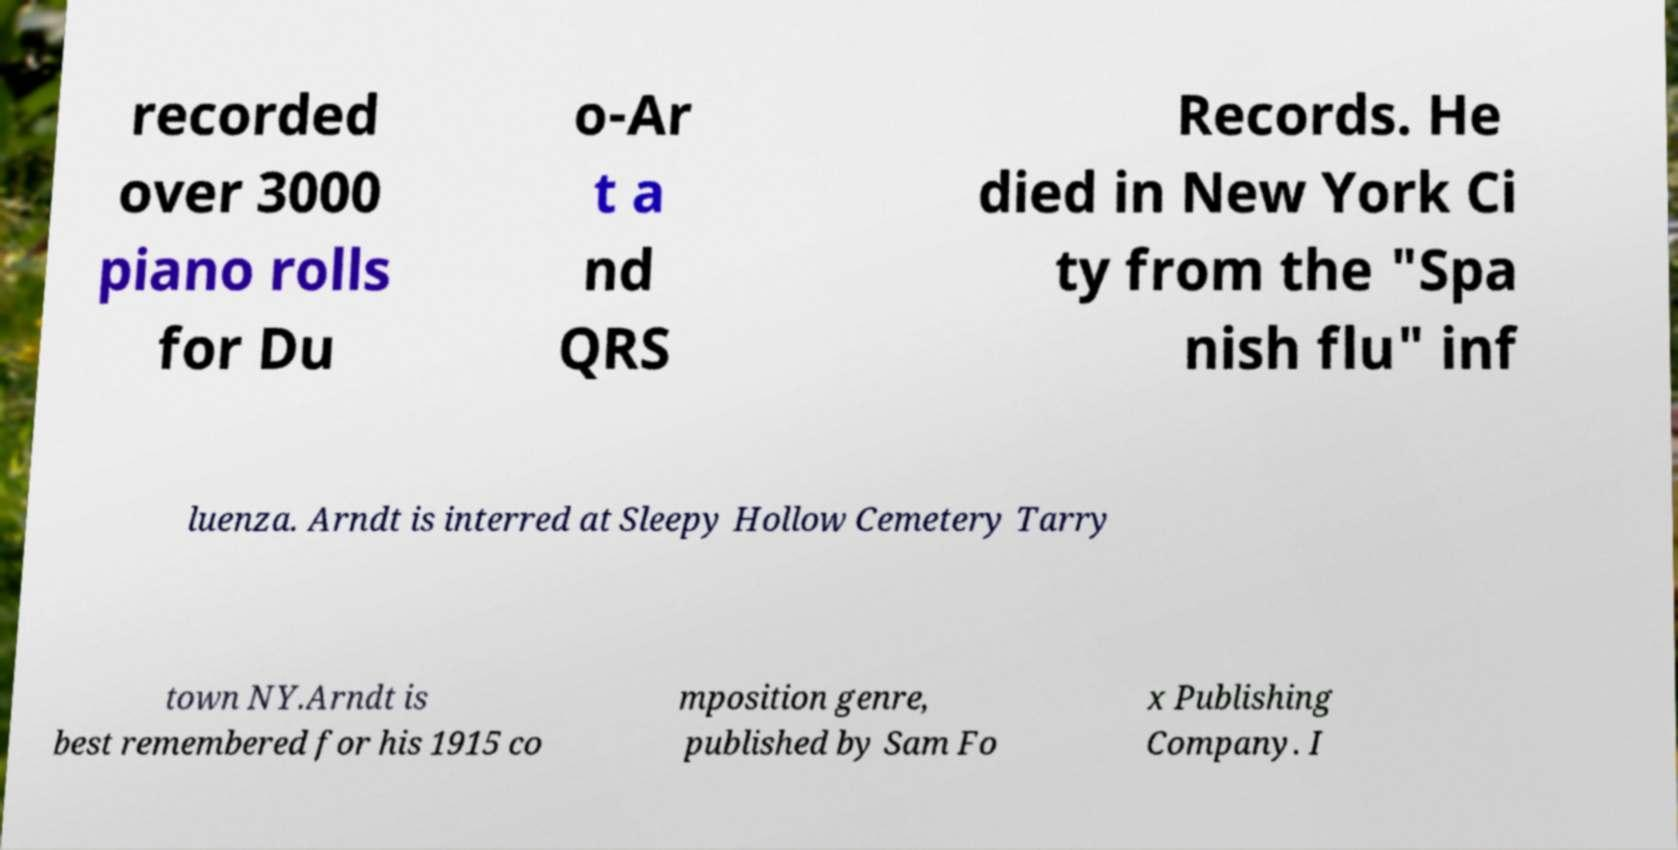Could you extract and type out the text from this image? recorded over 3000 piano rolls for Du o-Ar t a nd QRS Records. He died in New York Ci ty from the "Spa nish flu" inf luenza. Arndt is interred at Sleepy Hollow Cemetery Tarry town NY.Arndt is best remembered for his 1915 co mposition genre, published by Sam Fo x Publishing Company. I 